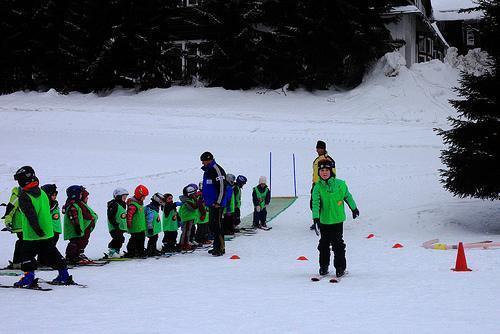How many cones are there?
Give a very brief answer. 1. 